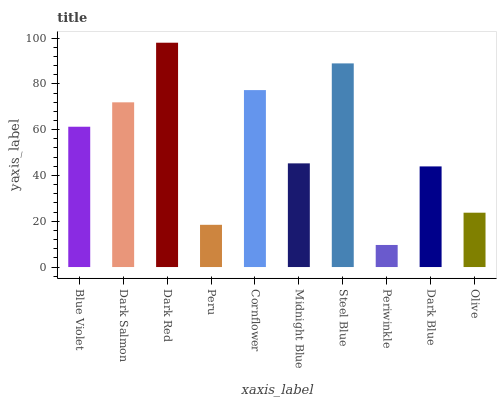Is Dark Salmon the minimum?
Answer yes or no. No. Is Dark Salmon the maximum?
Answer yes or no. No. Is Dark Salmon greater than Blue Violet?
Answer yes or no. Yes. Is Blue Violet less than Dark Salmon?
Answer yes or no. Yes. Is Blue Violet greater than Dark Salmon?
Answer yes or no. No. Is Dark Salmon less than Blue Violet?
Answer yes or no. No. Is Blue Violet the high median?
Answer yes or no. Yes. Is Midnight Blue the low median?
Answer yes or no. Yes. Is Peru the high median?
Answer yes or no. No. Is Dark Blue the low median?
Answer yes or no. No. 